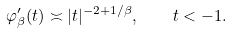<formula> <loc_0><loc_0><loc_500><loc_500>\varphi ^ { \prime } _ { \beta } ( t ) \asymp | t | ^ { - 2 + 1 / \beta } , \quad t < - 1 .</formula> 